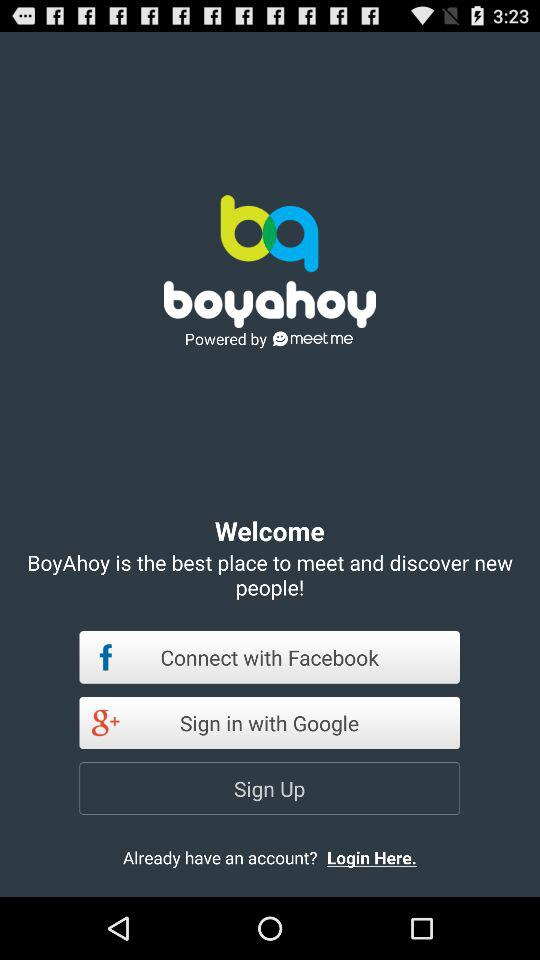What are the different options available for logging in? The different options available for logging in are "Facebook" and "Google". 